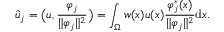Convert formula to latex. <formula><loc_0><loc_0><loc_500><loc_500>\widehat { u } _ { j } = \left ( u , \frac { \varphi _ { j } } { \| \varphi _ { j } \| ^ { 2 } } \right ) = \int _ { \Omega } w ( x ) u ( x ) \frac { \varphi _ { j } ^ { \ast } ( x ) } { \| \varphi _ { j } \| ^ { 2 } } d x .</formula> 